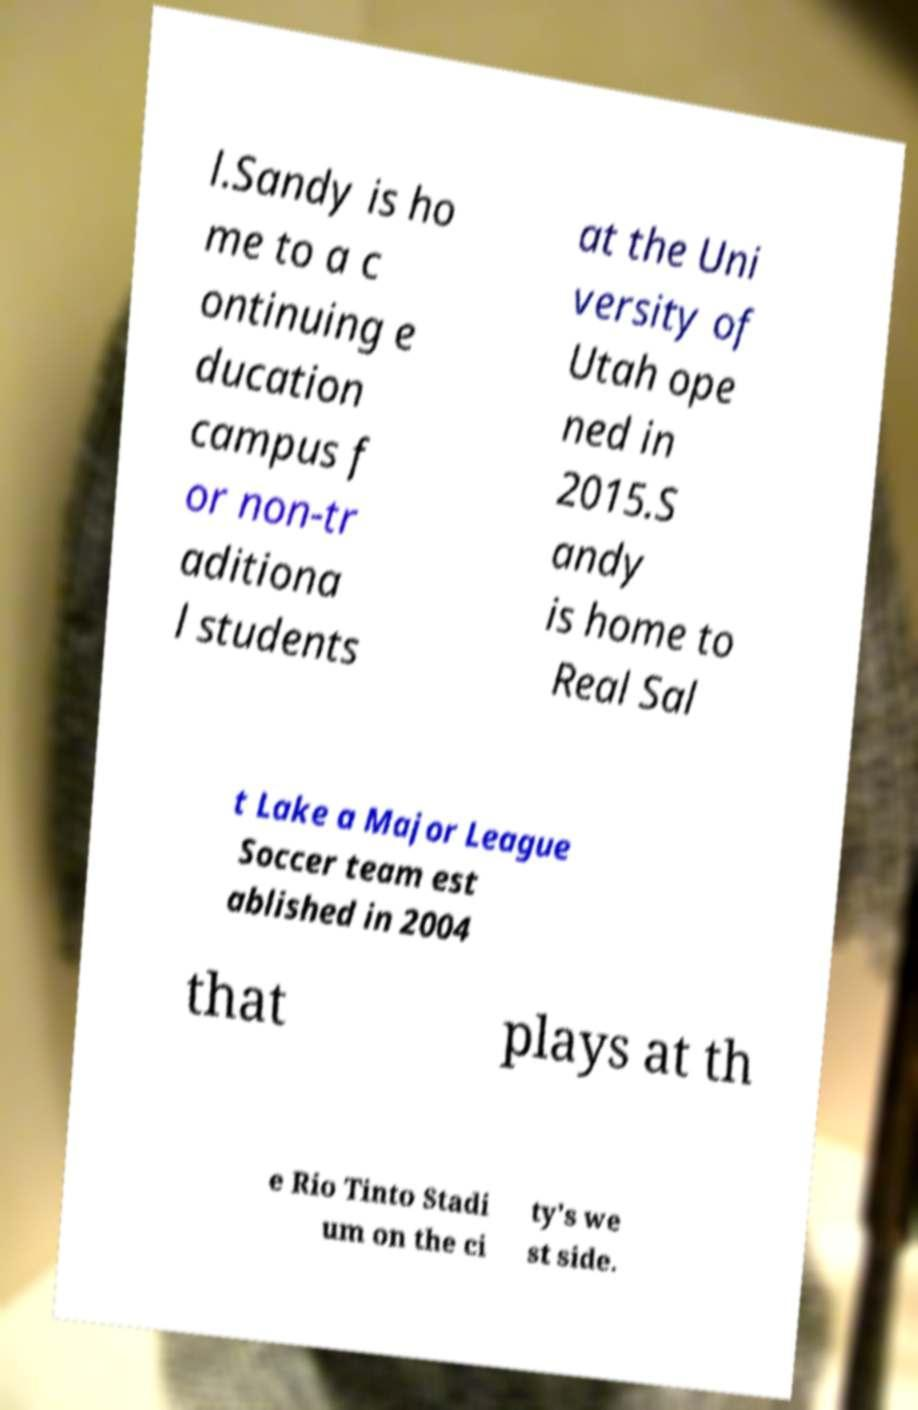What messages or text are displayed in this image? I need them in a readable, typed format. l.Sandy is ho me to a c ontinuing e ducation campus f or non-tr aditiona l students at the Uni versity of Utah ope ned in 2015.S andy is home to Real Sal t Lake a Major League Soccer team est ablished in 2004 that plays at th e Rio Tinto Stadi um on the ci ty's we st side. 